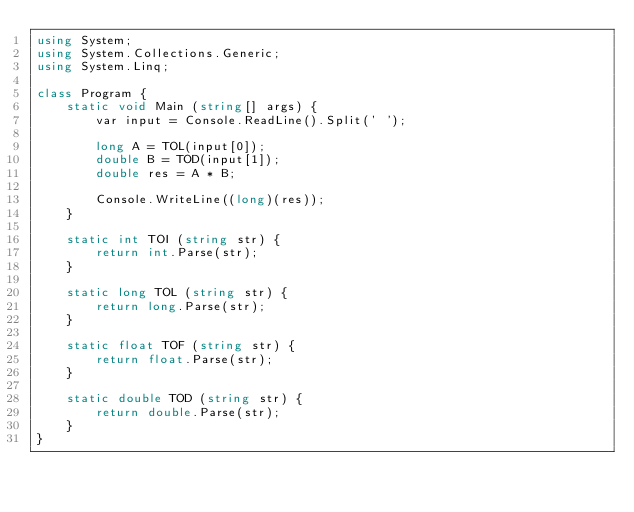Convert code to text. <code><loc_0><loc_0><loc_500><loc_500><_C#_>using System;
using System.Collections.Generic;
using System.Linq;

class Program {
    static void Main (string[] args) {
        var input = Console.ReadLine().Split(' ');

        long A = TOL(input[0]);
        double B = TOD(input[1]);
        double res = A * B;

        Console.WriteLine((long)(res));
    }

    static int TOI (string str) {
        return int.Parse(str);
    }

    static long TOL (string str) {
        return long.Parse(str);
    }

    static float TOF (string str) {
        return float.Parse(str);
    }

    static double TOD (string str) {
        return double.Parse(str);
    }
}</code> 